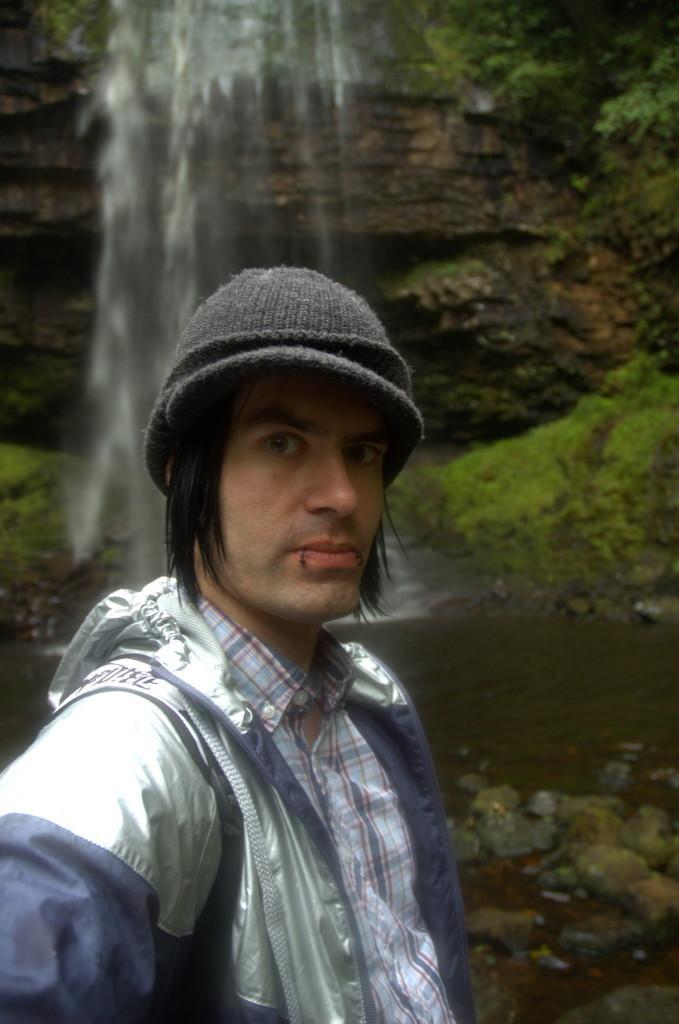Please provide a concise description of this image. There is one man standing and wearing a jacket and a cap at the bottom of this image. We can see a waterfall in the background. 